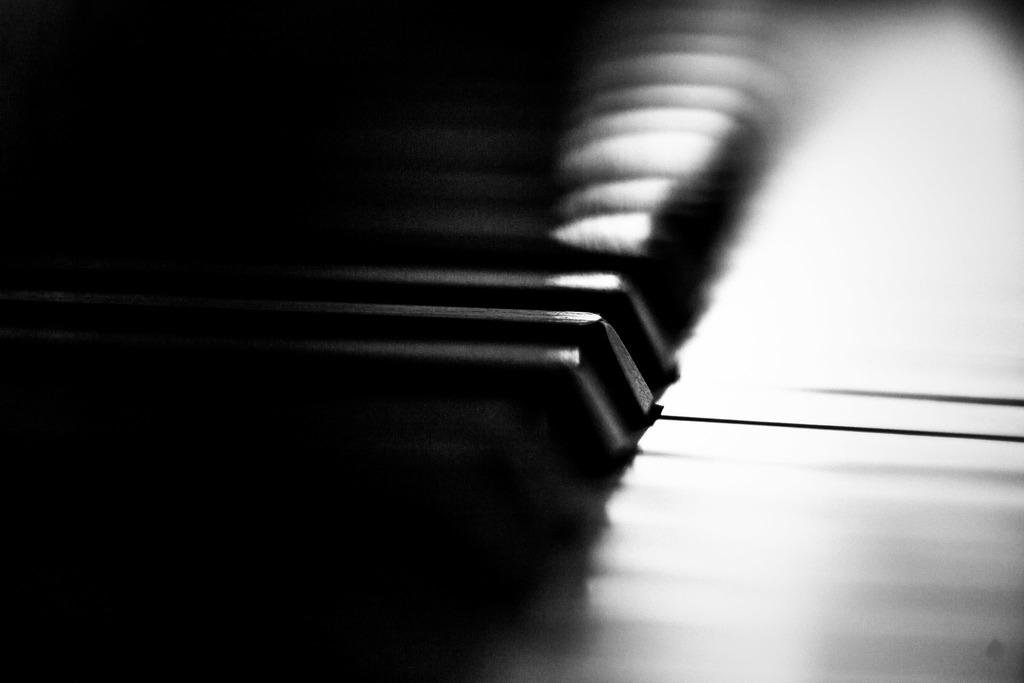What is the main object in the image? There is a piano in the image. Can you describe the background of the image? The background of the image is dark and blurred. Where is the tank located in the image? There is no tank present in the image. What type of recess is visible in the image? There is no recess visible in the image. 